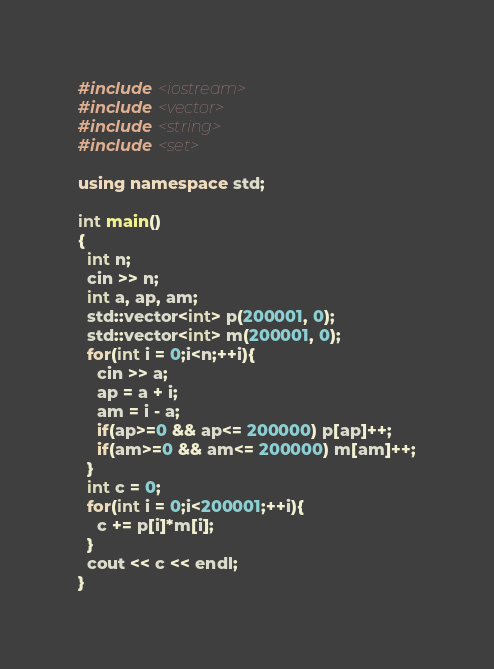<code> <loc_0><loc_0><loc_500><loc_500><_C++_>#include <iostream>
#include <vector>
#include <string>
#include <set>

using namespace std;

int main()
{
  int n;
  cin >> n;
  int a, ap, am;
  std::vector<int> p(200001, 0);
  std::vector<int> m(200001, 0);
  for(int i = 0;i<n;++i){
    cin >> a;
    ap = a + i;
    am = i - a;
    if(ap>=0 && ap<= 200000) p[ap]++;
    if(am>=0 && am<= 200000) m[am]++;
  }
  int c = 0;
  for(int i = 0;i<200001;++i){
    c += p[i]*m[i];
  }
  cout << c << endl;
}
</code> 